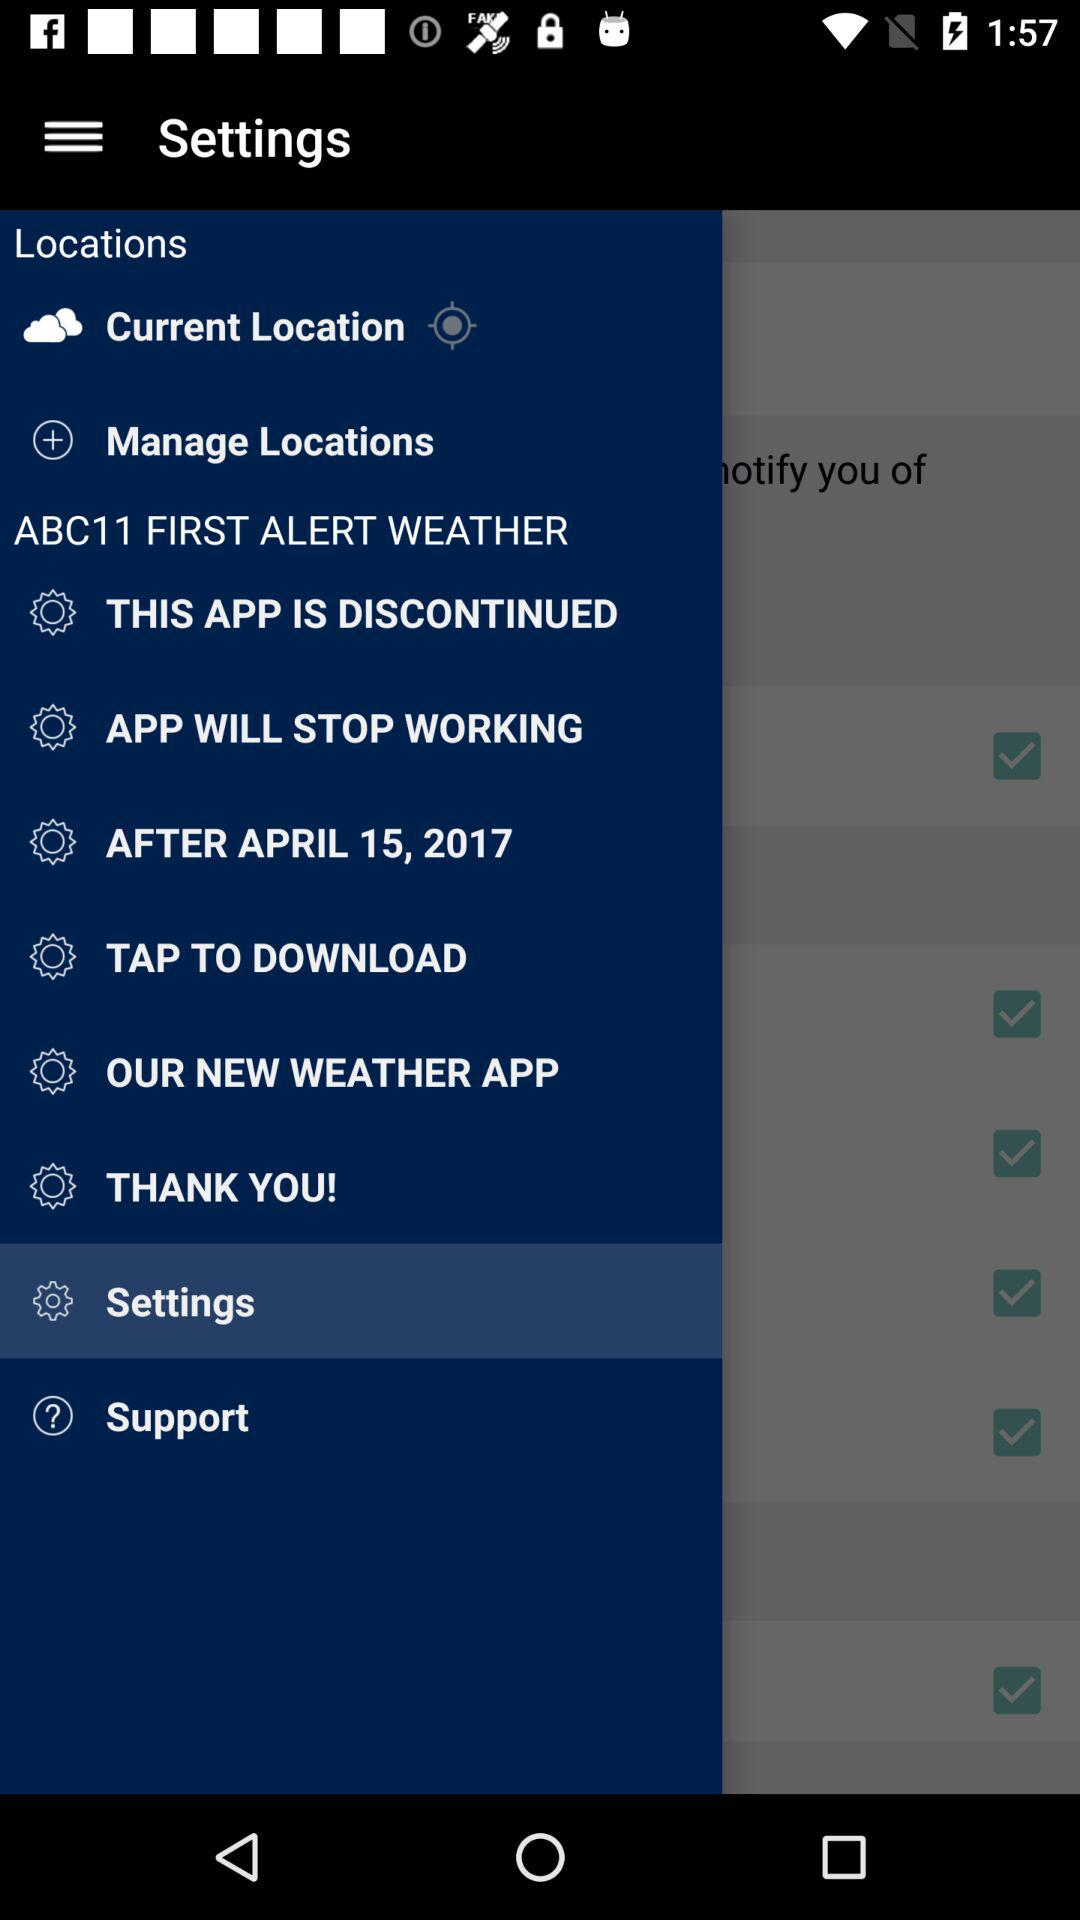Which item is selected? The selected item is "Settings". 